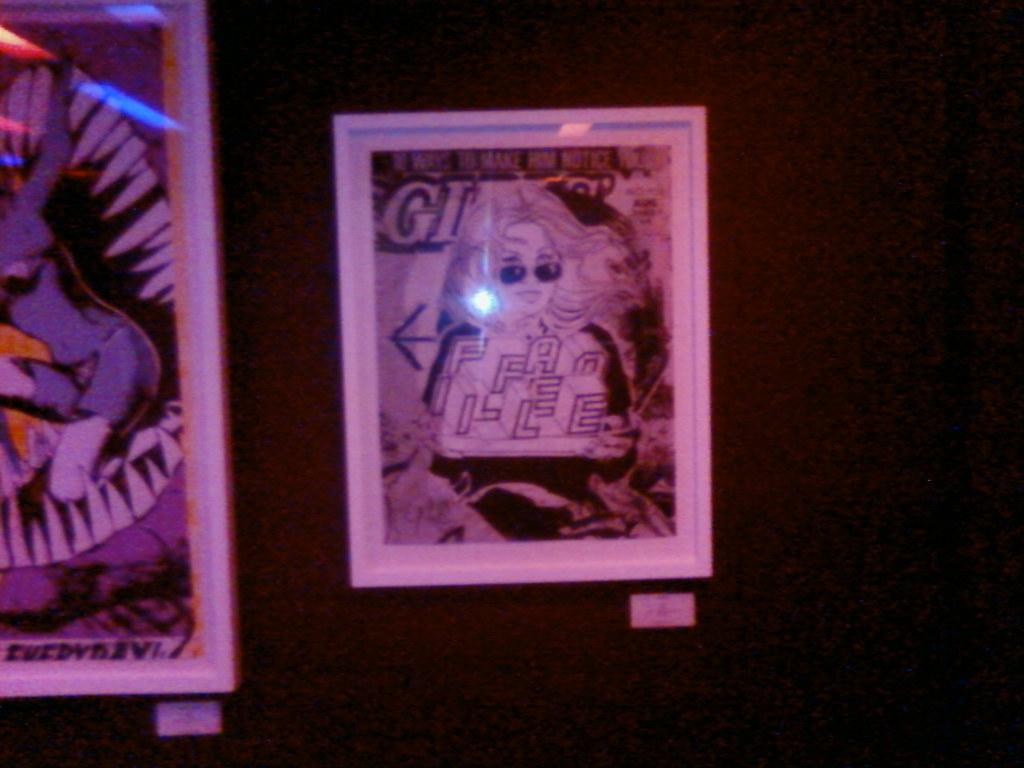<image>
Share a concise interpretation of the image provided. A framed poster has the letters GI in the upper left corner. 